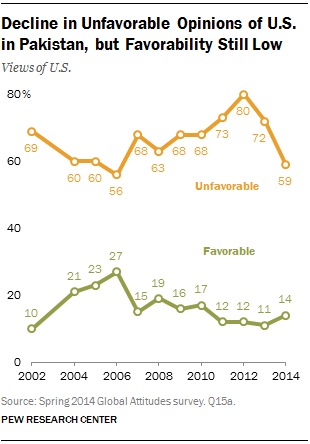Highlight a few significant elements in this photo. In 2012, the orange data points reached their peak. The median of the green data points for the years 2012 to 2014 is 0.15278... 